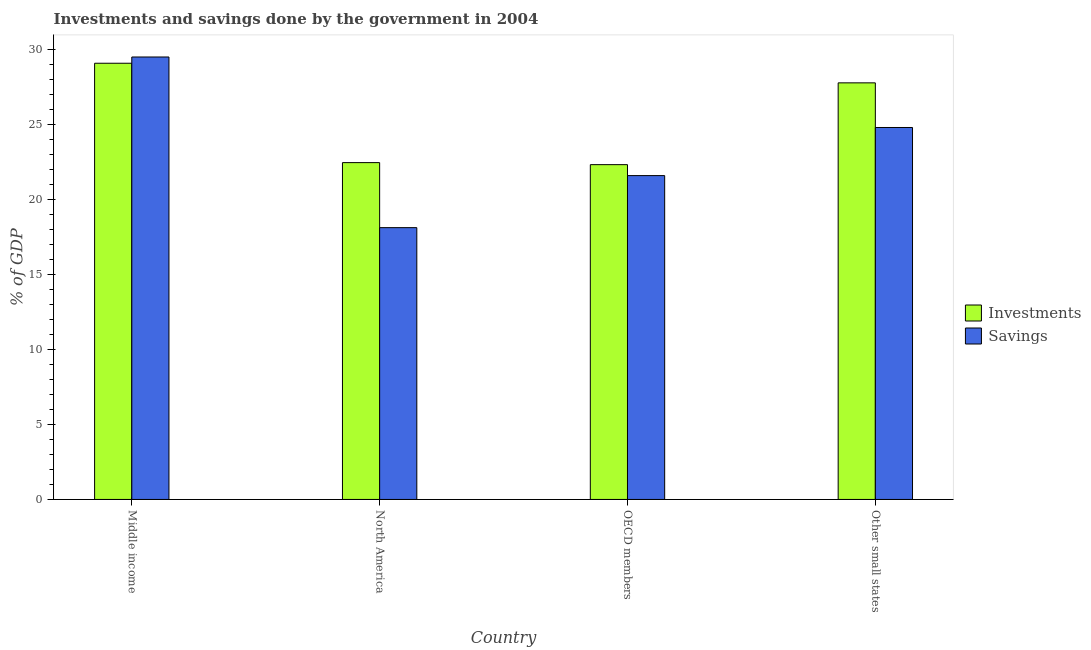How many groups of bars are there?
Provide a succinct answer. 4. Are the number of bars on each tick of the X-axis equal?
Your answer should be very brief. Yes. How many bars are there on the 3rd tick from the left?
Offer a very short reply. 2. In how many cases, is the number of bars for a given country not equal to the number of legend labels?
Give a very brief answer. 0. What is the investments of government in Middle income?
Offer a very short reply. 29.08. Across all countries, what is the maximum investments of government?
Your answer should be very brief. 29.08. Across all countries, what is the minimum investments of government?
Keep it short and to the point. 22.32. In which country was the investments of government maximum?
Offer a very short reply. Middle income. What is the total savings of government in the graph?
Your answer should be compact. 94. What is the difference between the savings of government in Middle income and that in OECD members?
Your answer should be compact. 7.91. What is the difference between the savings of government in OECD members and the investments of government in Middle income?
Offer a terse response. -7.49. What is the average savings of government per country?
Keep it short and to the point. 23.5. What is the difference between the savings of government and investments of government in North America?
Ensure brevity in your answer.  -4.33. What is the ratio of the savings of government in OECD members to that in Other small states?
Your answer should be compact. 0.87. Is the savings of government in North America less than that in Other small states?
Ensure brevity in your answer.  Yes. What is the difference between the highest and the second highest savings of government?
Keep it short and to the point. 4.7. What is the difference between the highest and the lowest investments of government?
Offer a terse response. 6.76. In how many countries, is the savings of government greater than the average savings of government taken over all countries?
Provide a short and direct response. 2. What does the 2nd bar from the left in OECD members represents?
Your response must be concise. Savings. What does the 1st bar from the right in Other small states represents?
Offer a terse response. Savings. Are all the bars in the graph horizontal?
Ensure brevity in your answer.  No. How many countries are there in the graph?
Offer a very short reply. 4. Does the graph contain any zero values?
Your answer should be compact. No. What is the title of the graph?
Your answer should be very brief. Investments and savings done by the government in 2004. What is the label or title of the X-axis?
Keep it short and to the point. Country. What is the label or title of the Y-axis?
Provide a short and direct response. % of GDP. What is the % of GDP of Investments in Middle income?
Make the answer very short. 29.08. What is the % of GDP in Savings in Middle income?
Offer a terse response. 29.49. What is the % of GDP of Investments in North America?
Your answer should be compact. 22.45. What is the % of GDP of Savings in North America?
Offer a very short reply. 18.12. What is the % of GDP in Investments in OECD members?
Offer a very short reply. 22.32. What is the % of GDP of Savings in OECD members?
Keep it short and to the point. 21.59. What is the % of GDP of Investments in Other small states?
Ensure brevity in your answer.  27.77. What is the % of GDP of Savings in Other small states?
Offer a terse response. 24.79. Across all countries, what is the maximum % of GDP in Investments?
Your answer should be compact. 29.08. Across all countries, what is the maximum % of GDP of Savings?
Your answer should be compact. 29.49. Across all countries, what is the minimum % of GDP in Investments?
Your answer should be compact. 22.32. Across all countries, what is the minimum % of GDP of Savings?
Make the answer very short. 18.12. What is the total % of GDP of Investments in the graph?
Provide a succinct answer. 101.62. What is the total % of GDP in Savings in the graph?
Offer a terse response. 94. What is the difference between the % of GDP of Investments in Middle income and that in North America?
Give a very brief answer. 6.62. What is the difference between the % of GDP in Savings in Middle income and that in North America?
Keep it short and to the point. 11.38. What is the difference between the % of GDP of Investments in Middle income and that in OECD members?
Your answer should be compact. 6.76. What is the difference between the % of GDP in Savings in Middle income and that in OECD members?
Your answer should be very brief. 7.91. What is the difference between the % of GDP of Investments in Middle income and that in Other small states?
Ensure brevity in your answer.  1.31. What is the difference between the % of GDP of Savings in Middle income and that in Other small states?
Offer a very short reply. 4.7. What is the difference between the % of GDP of Investments in North America and that in OECD members?
Provide a short and direct response. 0.14. What is the difference between the % of GDP in Savings in North America and that in OECD members?
Your answer should be very brief. -3.47. What is the difference between the % of GDP in Investments in North America and that in Other small states?
Keep it short and to the point. -5.32. What is the difference between the % of GDP of Savings in North America and that in Other small states?
Give a very brief answer. -6.68. What is the difference between the % of GDP in Investments in OECD members and that in Other small states?
Your answer should be very brief. -5.45. What is the difference between the % of GDP of Savings in OECD members and that in Other small states?
Offer a terse response. -3.21. What is the difference between the % of GDP in Investments in Middle income and the % of GDP in Savings in North America?
Your response must be concise. 10.96. What is the difference between the % of GDP in Investments in Middle income and the % of GDP in Savings in OECD members?
Your response must be concise. 7.49. What is the difference between the % of GDP in Investments in Middle income and the % of GDP in Savings in Other small states?
Offer a very short reply. 4.28. What is the difference between the % of GDP of Investments in North America and the % of GDP of Savings in OECD members?
Provide a succinct answer. 0.87. What is the difference between the % of GDP in Investments in North America and the % of GDP in Savings in Other small states?
Give a very brief answer. -2.34. What is the difference between the % of GDP of Investments in OECD members and the % of GDP of Savings in Other small states?
Make the answer very short. -2.48. What is the average % of GDP in Investments per country?
Keep it short and to the point. 25.41. What is the average % of GDP in Savings per country?
Offer a very short reply. 23.5. What is the difference between the % of GDP in Investments and % of GDP in Savings in Middle income?
Provide a succinct answer. -0.42. What is the difference between the % of GDP of Investments and % of GDP of Savings in North America?
Your answer should be compact. 4.33. What is the difference between the % of GDP in Investments and % of GDP in Savings in OECD members?
Your response must be concise. 0.73. What is the difference between the % of GDP in Investments and % of GDP in Savings in Other small states?
Provide a succinct answer. 2.98. What is the ratio of the % of GDP of Investments in Middle income to that in North America?
Offer a very short reply. 1.29. What is the ratio of the % of GDP in Savings in Middle income to that in North America?
Offer a terse response. 1.63. What is the ratio of the % of GDP in Investments in Middle income to that in OECD members?
Offer a terse response. 1.3. What is the ratio of the % of GDP of Savings in Middle income to that in OECD members?
Your answer should be compact. 1.37. What is the ratio of the % of GDP in Investments in Middle income to that in Other small states?
Offer a very short reply. 1.05. What is the ratio of the % of GDP of Savings in Middle income to that in Other small states?
Provide a short and direct response. 1.19. What is the ratio of the % of GDP of Savings in North America to that in OECD members?
Provide a succinct answer. 0.84. What is the ratio of the % of GDP of Investments in North America to that in Other small states?
Provide a succinct answer. 0.81. What is the ratio of the % of GDP in Savings in North America to that in Other small states?
Offer a very short reply. 0.73. What is the ratio of the % of GDP of Investments in OECD members to that in Other small states?
Provide a succinct answer. 0.8. What is the ratio of the % of GDP of Savings in OECD members to that in Other small states?
Give a very brief answer. 0.87. What is the difference between the highest and the second highest % of GDP of Investments?
Keep it short and to the point. 1.31. What is the difference between the highest and the second highest % of GDP in Savings?
Offer a very short reply. 4.7. What is the difference between the highest and the lowest % of GDP in Investments?
Provide a short and direct response. 6.76. What is the difference between the highest and the lowest % of GDP in Savings?
Your answer should be compact. 11.38. 